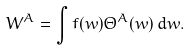Convert formula to latex. <formula><loc_0><loc_0><loc_500><loc_500>W ^ { A } = \int f ( w ) \Theta ^ { A } ( w ) \, d w .</formula> 